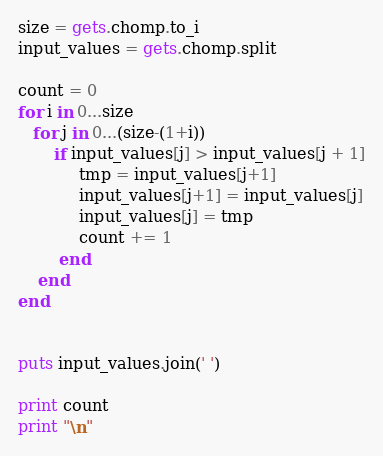Convert code to text. <code><loc_0><loc_0><loc_500><loc_500><_Ruby_>size = gets.chomp.to_i
input_values = gets.chomp.split

count = 0
for i in 0...size
   for j in 0...(size-(1+i))
       if input_values[j] > input_values[j + 1]
            tmp = input_values[j+1]
            input_values[j+1] = input_values[j]
            input_values[j] = tmp
            count += 1
        end
    end
end


puts input_values.join(' ')

print count
print "\n"</code> 